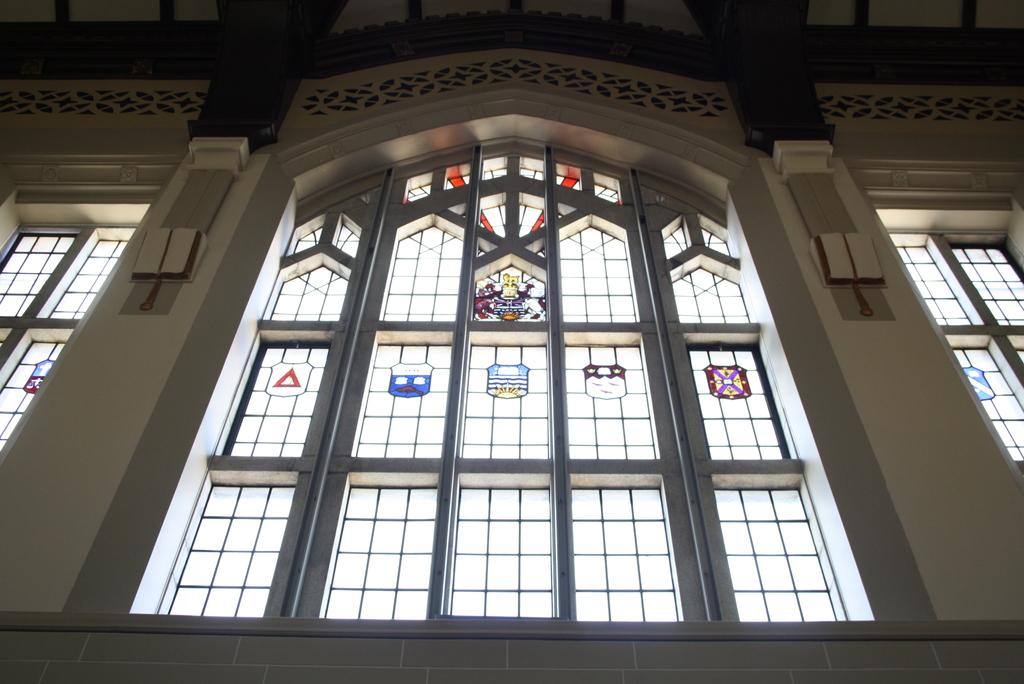What type of location is depicted in the image? The image shows an inside view of a building. What can be seen on the windows in the image? There are windows with labels in the image. What is featured on the wall in the image? There is a wall with a design in the image. What type of prison is depicted in the image? There is no prison present in the image; it shows an inside view of a building with windows and a wall with a design. What type of paste is used to create the design on the wall in the image? There is no information about the materials used to create the design on the wall in the image. 